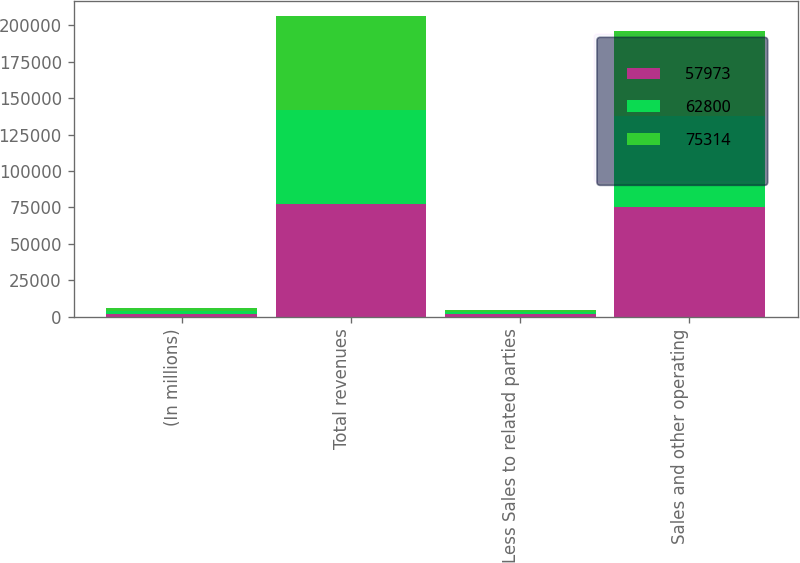Convert chart. <chart><loc_0><loc_0><loc_500><loc_500><stacked_bar_chart><ecel><fcel>(In millions)<fcel>Total revenues<fcel>Less Sales to related parties<fcel>Sales and other operating<nl><fcel>57973<fcel>2008<fcel>77193<fcel>1879<fcel>75314<nl><fcel>62800<fcel>2007<fcel>64552<fcel>1625<fcel>62800<nl><fcel>75314<fcel>2006<fcel>64896<fcel>1466<fcel>57973<nl></chart> 